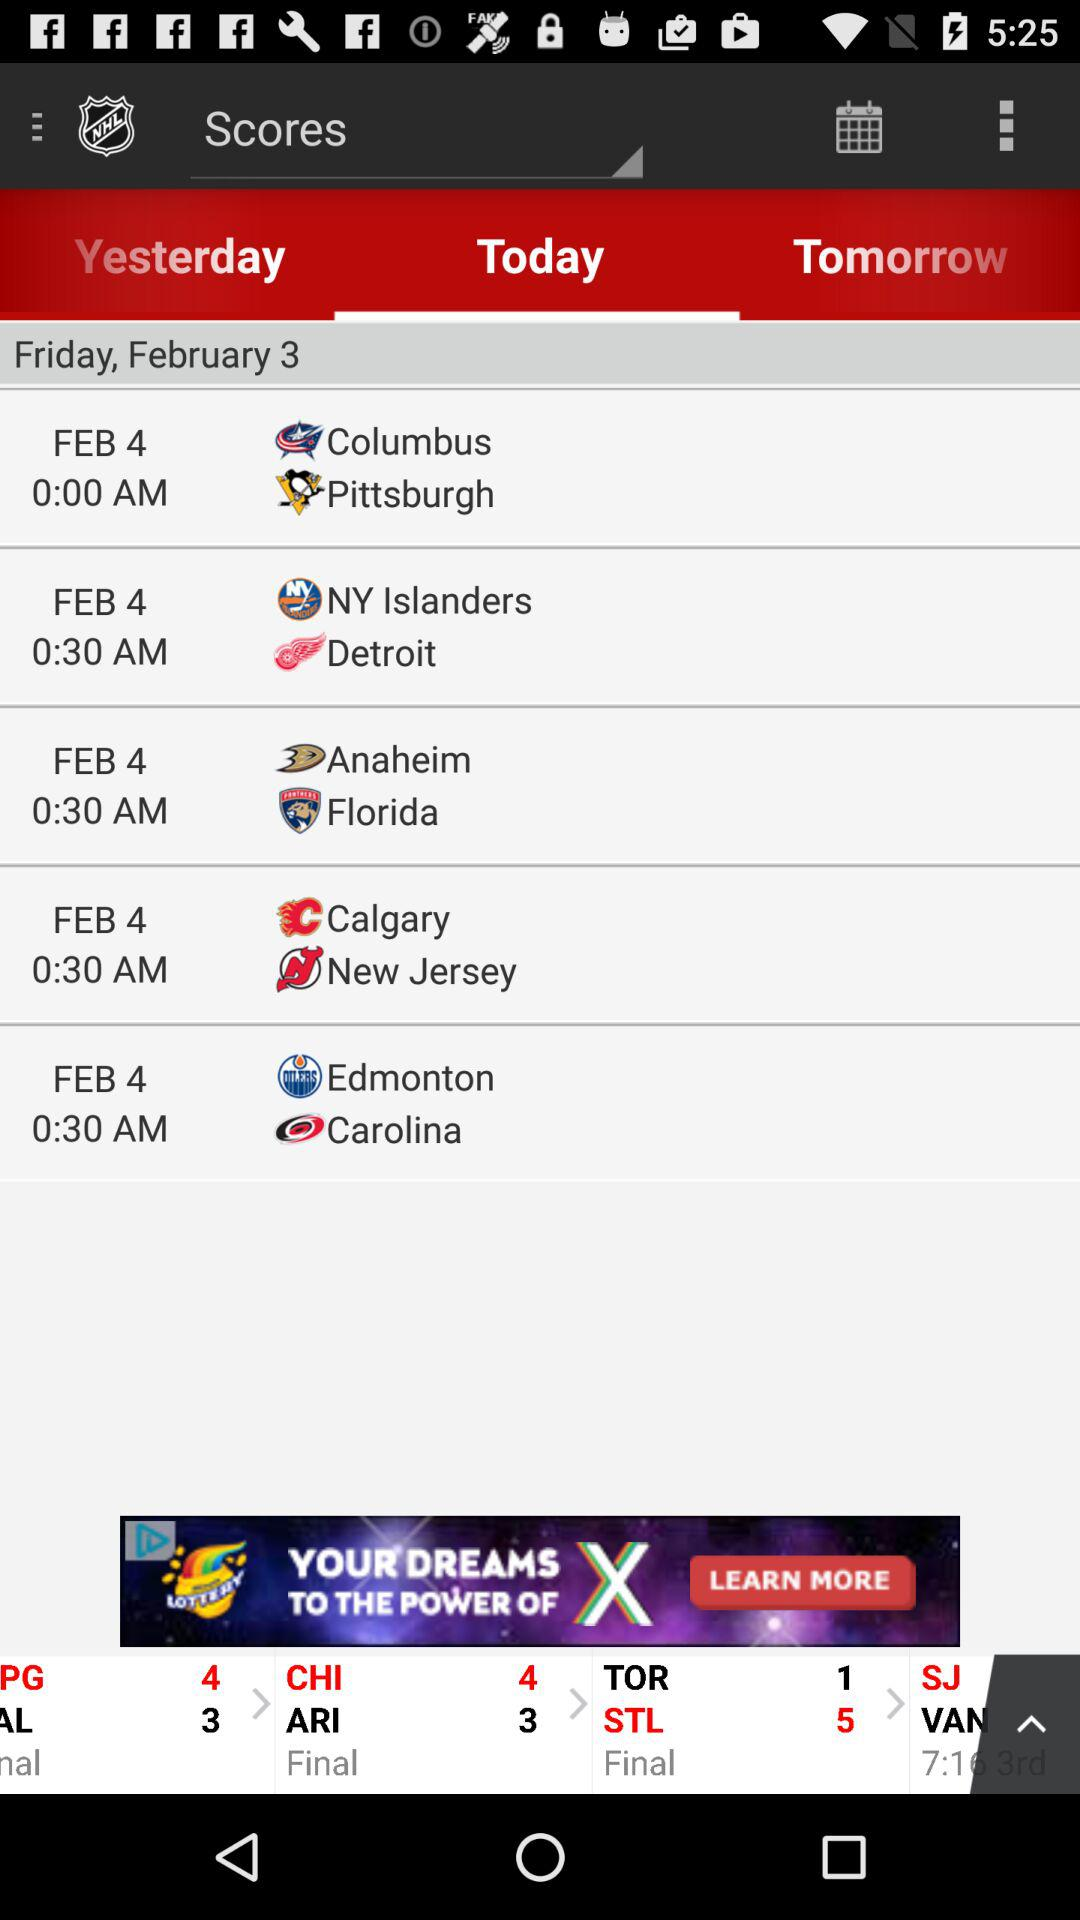What is the mentioned day? The mentioned day is Friday. 